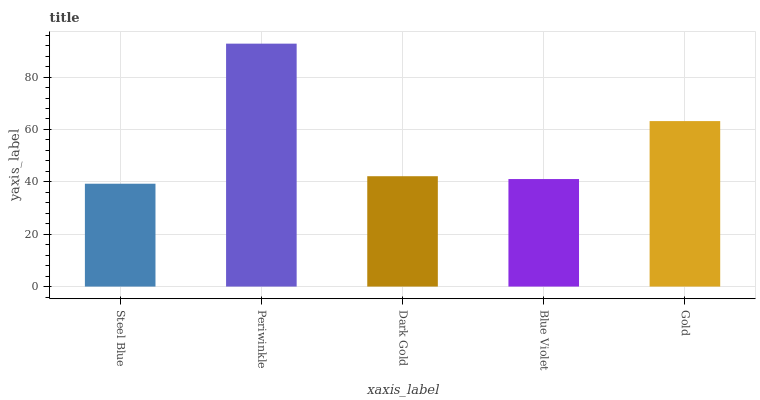Is Steel Blue the minimum?
Answer yes or no. Yes. Is Periwinkle the maximum?
Answer yes or no. Yes. Is Dark Gold the minimum?
Answer yes or no. No. Is Dark Gold the maximum?
Answer yes or no. No. Is Periwinkle greater than Dark Gold?
Answer yes or no. Yes. Is Dark Gold less than Periwinkle?
Answer yes or no. Yes. Is Dark Gold greater than Periwinkle?
Answer yes or no. No. Is Periwinkle less than Dark Gold?
Answer yes or no. No. Is Dark Gold the high median?
Answer yes or no. Yes. Is Dark Gold the low median?
Answer yes or no. Yes. Is Periwinkle the high median?
Answer yes or no. No. Is Gold the low median?
Answer yes or no. No. 